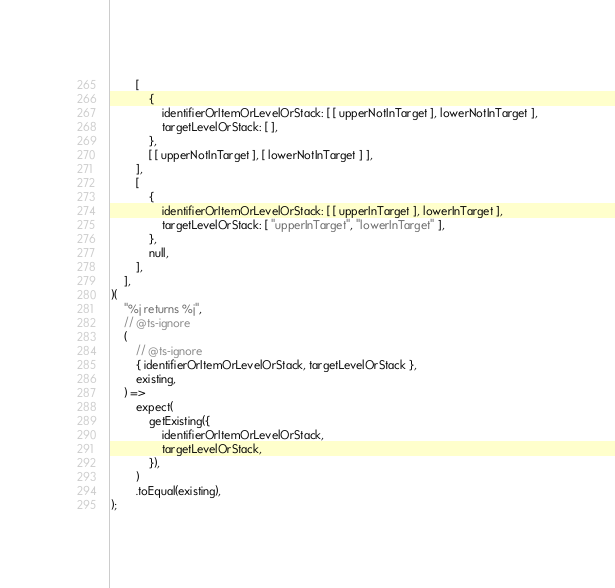Convert code to text. <code><loc_0><loc_0><loc_500><loc_500><_JavaScript_>		[
			{
				identifierOrItemOrLevelOrStack: [ [ upperNotInTarget ], lowerNotInTarget ],
				targetLevelOrStack: [ ],
			},
			[ [ upperNotInTarget ], [ lowerNotInTarget ] ],
		],
		[
			{
				identifierOrItemOrLevelOrStack: [ [ upperInTarget ], lowerInTarget ],
				targetLevelOrStack: [ "upperInTarget", "lowerInTarget" ],
			},
			null,
		],
	],
)(
	"%j returns %j",
	// @ts-ignore
	(
		// @ts-ignore
		{ identifierOrItemOrLevelOrStack, targetLevelOrStack },
		existing,
	) =>
		expect(
			getExisting({
				identifierOrItemOrLevelOrStack,
				targetLevelOrStack,
			}),
		)
		.toEqual(existing),
);</code> 